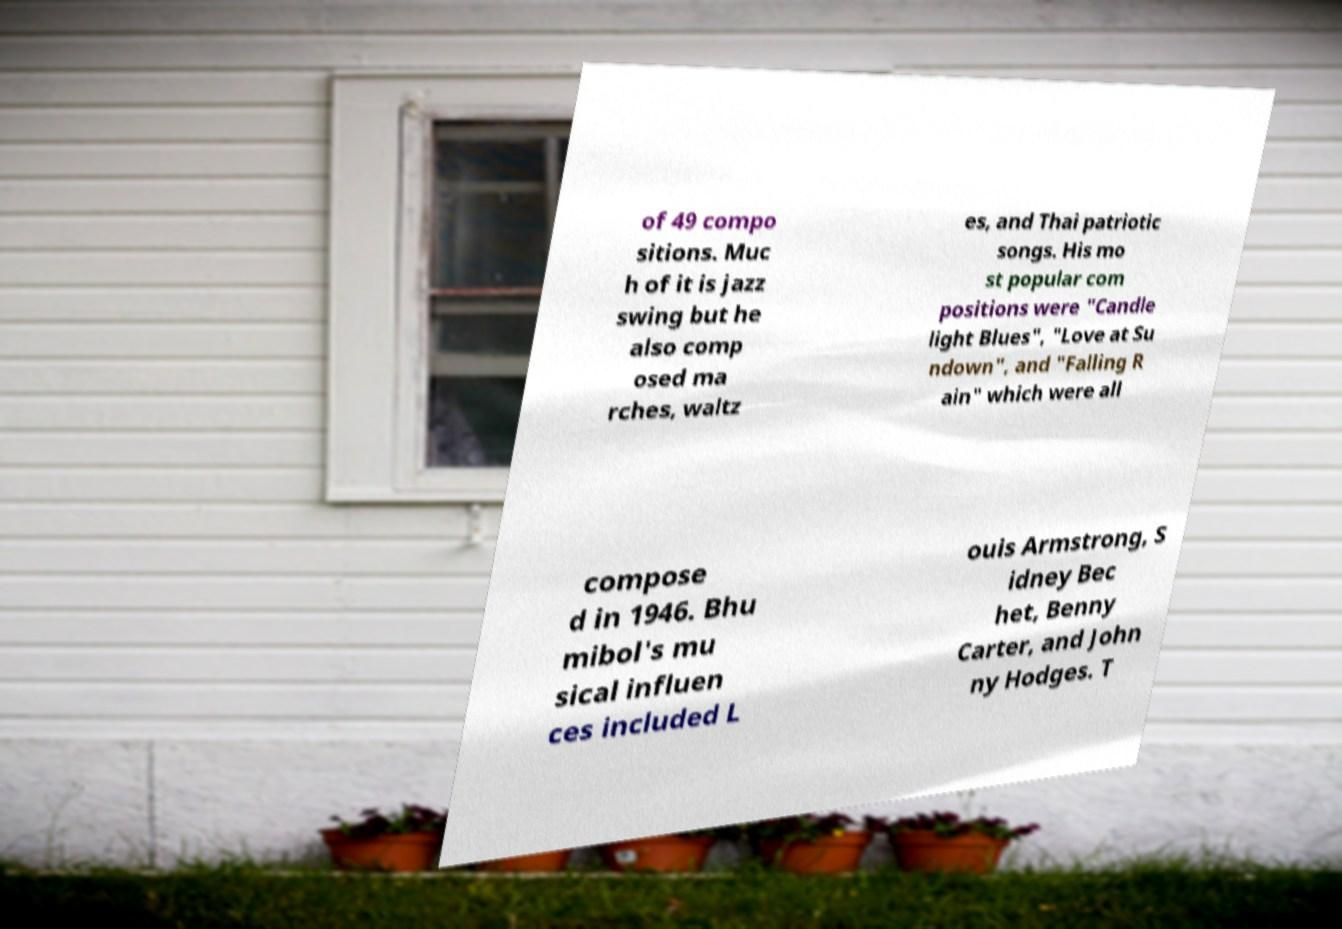I need the written content from this picture converted into text. Can you do that? of 49 compo sitions. Muc h of it is jazz swing but he also comp osed ma rches, waltz es, and Thai patriotic songs. His mo st popular com positions were "Candle light Blues", "Love at Su ndown", and "Falling R ain" which were all compose d in 1946. Bhu mibol's mu sical influen ces included L ouis Armstrong, S idney Bec het, Benny Carter, and John ny Hodges. T 